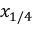Convert formula to latex. <formula><loc_0><loc_0><loc_500><loc_500>x _ { 1 / 4 }</formula> 